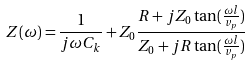Convert formula to latex. <formula><loc_0><loc_0><loc_500><loc_500>Z ( \omega ) = \frac { 1 } { j \omega C _ { k } } + Z _ { 0 } \frac { R + j Z _ { 0 } \tan ( \frac { \omega l } { v _ { p } } ) } { Z _ { 0 } + j R \tan ( \frac { \omega l } { v _ { p } } ) }</formula> 